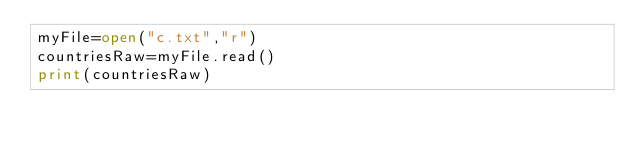Convert code to text. <code><loc_0><loc_0><loc_500><loc_500><_Python_>myFile=open("c.txt","r")
countriesRaw=myFile.read()
print(countriesRaw)</code> 